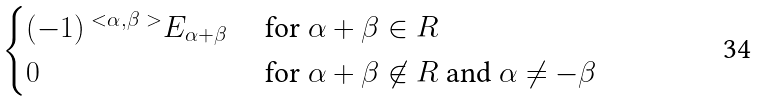Convert formula to latex. <formula><loc_0><loc_0><loc_500><loc_500>\begin{cases} ( - 1 ) ^ { \ < \alpha , \beta \ > } E _ { \alpha + \beta } & \text { for } \alpha + \beta \in R \\ 0 & \text { for } \alpha + \beta \not \in R \text { and } \alpha \neq - \beta \end{cases}</formula> 